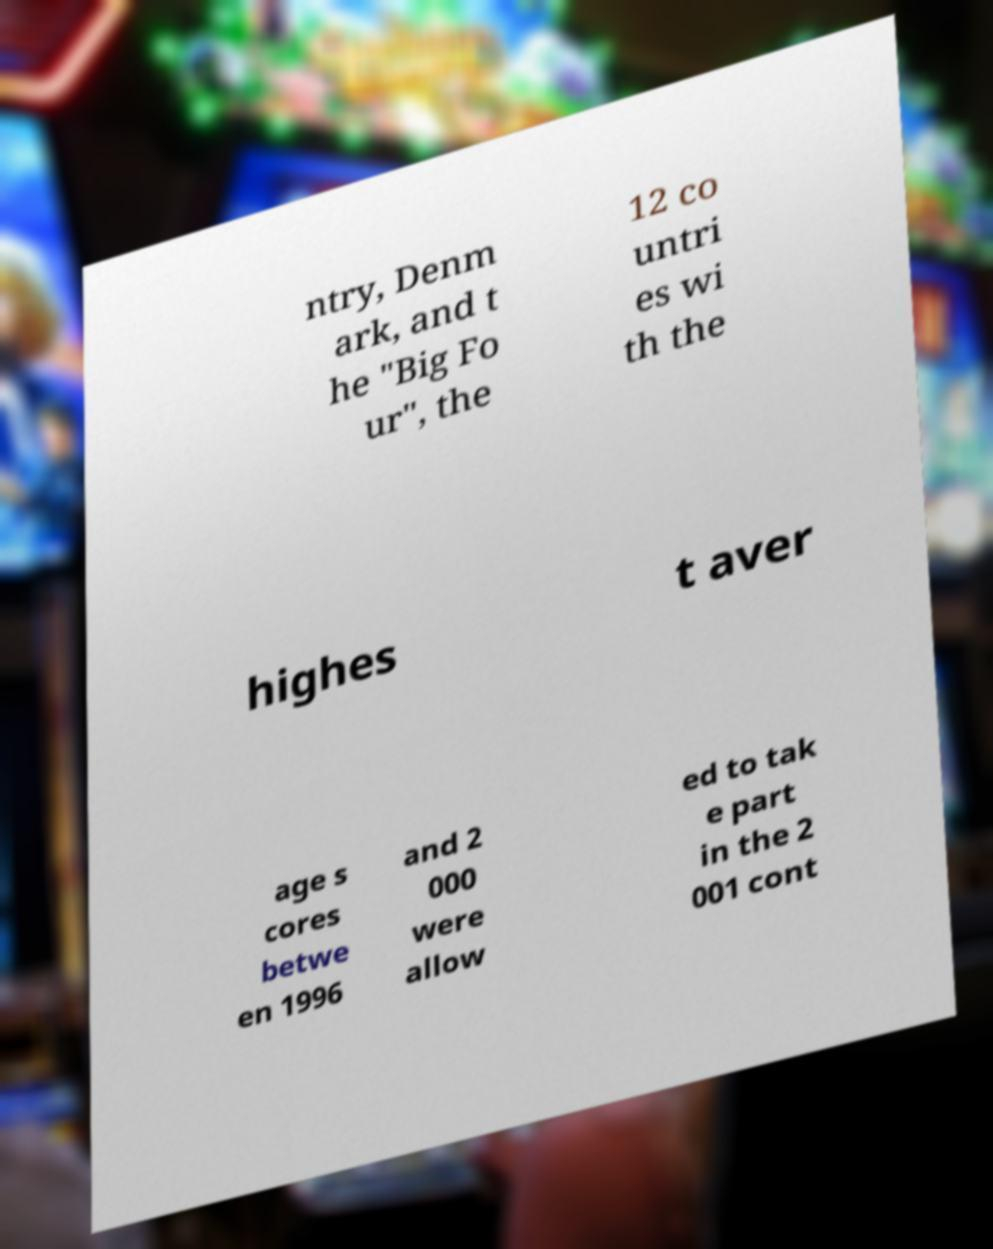Can you read and provide the text displayed in the image?This photo seems to have some interesting text. Can you extract and type it out for me? ntry, Denm ark, and t he "Big Fo ur", the 12 co untri es wi th the highes t aver age s cores betwe en 1996 and 2 000 were allow ed to tak e part in the 2 001 cont 